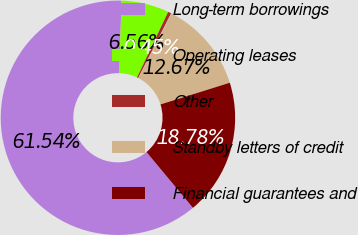Convert chart. <chart><loc_0><loc_0><loc_500><loc_500><pie_chart><fcel>Long-term borrowings<fcel>Operating leases<fcel>Other<fcel>Standby letters of credit<fcel>Financial guarantees and<nl><fcel>61.54%<fcel>6.56%<fcel>0.45%<fcel>12.67%<fcel>18.78%<nl></chart> 